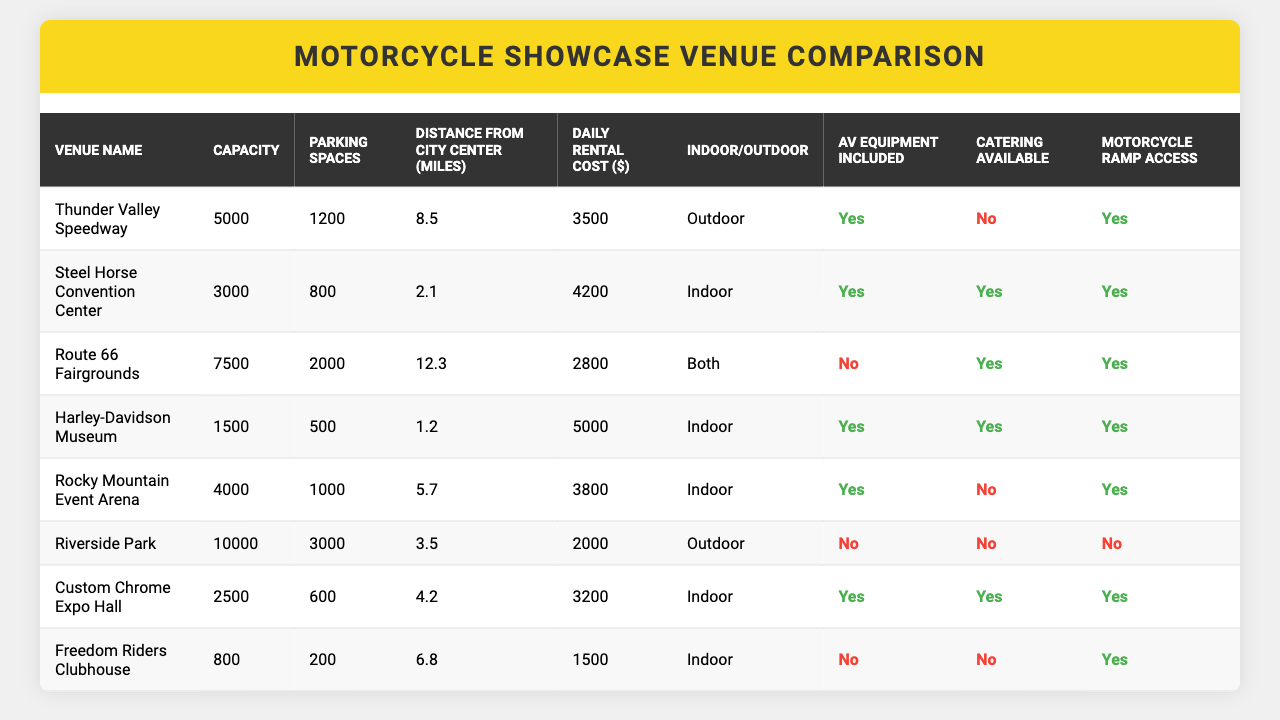What is the venue with the highest capacity? By examining the Capacity column, I see that Riverside Park has the highest number at 10,000.
Answer: Riverside Park Which venue is the closest to the city center? The Distance from City Center column shows Harley-Davidson Museum at 1.2 miles, which is the smallest distance.
Answer: Harley-Davidson Museum What are the total parking spaces available across all venues? I will sum the Parking Spaces values for all venues: 1200 + 800 + 2000 + 500 + 1000 + 3000 + 600 + 200 = 10300.
Answer: 10300 How many venues have outdoor options? By looking at the Indoor/Outdoor column, there are two venues listed as Outdoor: Thunder Valley Speedway and Riverside Park.
Answer: 2 Is catering available at Route 66 Fairgrounds? Checking the Catering Available column for Route 66 Fairgrounds, I see it says Yes.
Answer: Yes Which venue has the lowest daily rental cost? Comparing the Daily Rental Cost column, I find that Freedom Riders Clubhouse has the lowest cost at $1500.
Answer: Freedom Riders Clubhouse What is the average daily rental cost of all venues? First, I add up the daily rental costs: (3500 + 4200 + 2800 + 5000 + 3800 + 2000 + 3200 + 1500) = 21000. There are 8 venues, so I divide by 8: 21000 / 8 = 2625.
Answer: 2625 Do any of the venues include AV equipment and also offer catering? By checking both the AV Equipment Included and Catering Available columns, I see Steel Horse Convention Center and Harley-Davidson Museum meet both criteria.
Answer: Yes What is the difference in capacity between the venue with the most parking spaces and the venue with the least? The venue with the most parking spaces is Riverside Park (3000), and the venue with the least is Freedom Riders Clubhouse (200). The difference is 3000 - 200 = 2800.
Answer: 2800 Do all venues have motorcycle ramp access? Checking the Motorcycle Ramp Access column, I see not all venues have this; for example, Riverside Park and Freedom Riders Clubhouse do not.
Answer: No 